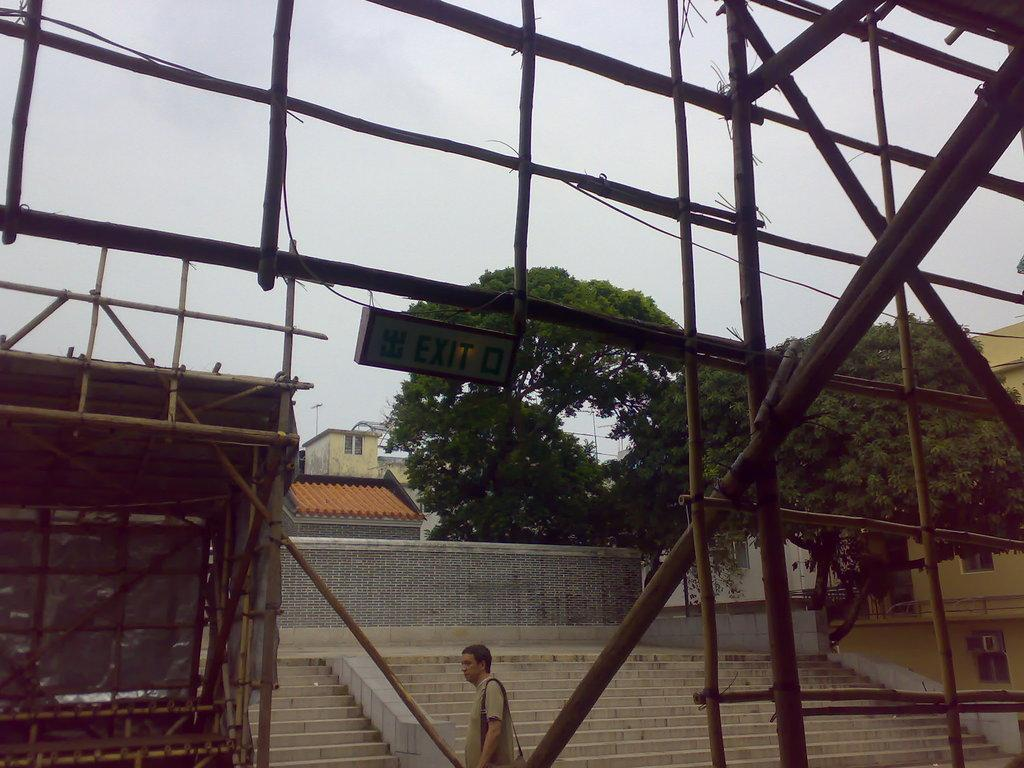Who is present at the bottom of the image? There is a man present at the bottom of the image. What can be seen in the background of the image? There are stairs, buildings, trees, and the sky visible in the background. Can you describe the setting of the image? The image appears to be set in an urban environment, with buildings and stairs in the background. What type of substance is being celebrated in the image? There is no indication of a celebration or substance being celebrated in the image. Can you see a nest in the image? There is no nest present in the image. 